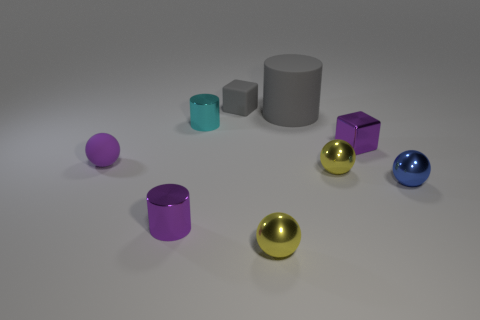What color is the other shiny cylinder that is the same size as the cyan metallic cylinder? purple 